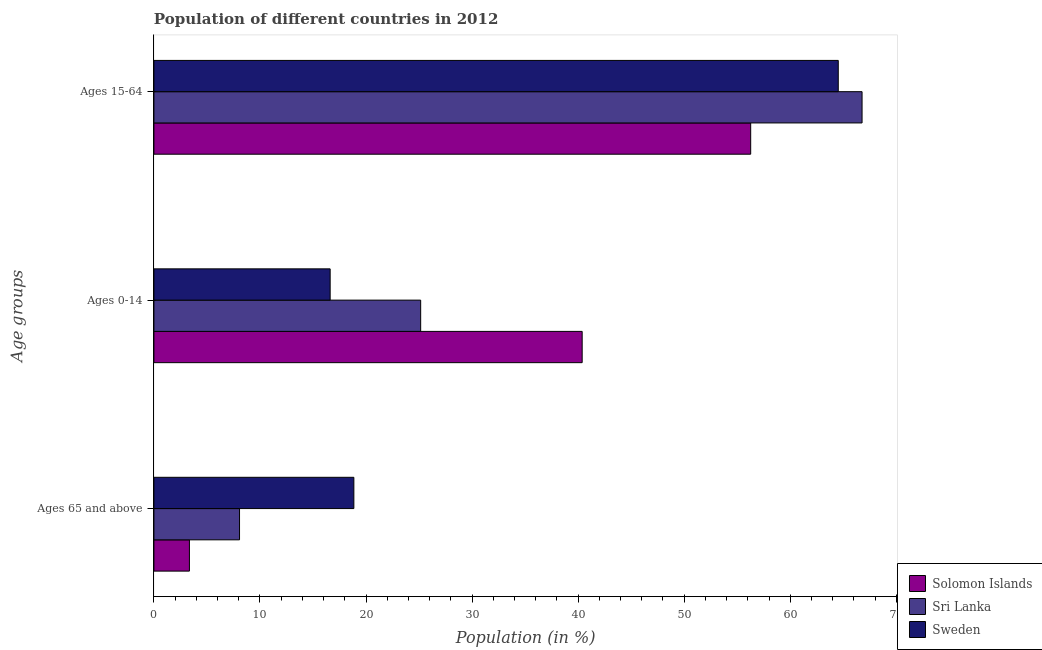How many different coloured bars are there?
Give a very brief answer. 3. Are the number of bars per tick equal to the number of legend labels?
Your answer should be compact. Yes. What is the label of the 1st group of bars from the top?
Make the answer very short. Ages 15-64. What is the percentage of population within the age-group of 65 and above in Sri Lanka?
Offer a very short reply. 8.07. Across all countries, what is the maximum percentage of population within the age-group 15-64?
Offer a very short reply. 66.77. Across all countries, what is the minimum percentage of population within the age-group of 65 and above?
Your response must be concise. 3.35. In which country was the percentage of population within the age-group 15-64 maximum?
Give a very brief answer. Sri Lanka. In which country was the percentage of population within the age-group 15-64 minimum?
Ensure brevity in your answer.  Solomon Islands. What is the total percentage of population within the age-group of 65 and above in the graph?
Make the answer very short. 30.27. What is the difference between the percentage of population within the age-group of 65 and above in Sri Lanka and that in Sweden?
Ensure brevity in your answer.  -10.78. What is the difference between the percentage of population within the age-group of 65 and above in Sri Lanka and the percentage of population within the age-group 15-64 in Sweden?
Provide a succinct answer. -56.46. What is the average percentage of population within the age-group of 65 and above per country?
Keep it short and to the point. 10.09. What is the difference between the percentage of population within the age-group of 65 and above and percentage of population within the age-group 15-64 in Sweden?
Provide a succinct answer. -45.68. What is the ratio of the percentage of population within the age-group 0-14 in Sri Lanka to that in Solomon Islands?
Your answer should be compact. 0.62. Is the difference between the percentage of population within the age-group 15-64 in Sweden and Solomon Islands greater than the difference between the percentage of population within the age-group of 65 and above in Sweden and Solomon Islands?
Ensure brevity in your answer.  No. What is the difference between the highest and the second highest percentage of population within the age-group 0-14?
Your answer should be very brief. 15.23. What is the difference between the highest and the lowest percentage of population within the age-group 0-14?
Make the answer very short. 23.76. What does the 1st bar from the top in Ages 0-14 represents?
Keep it short and to the point. Sweden. What does the 2nd bar from the bottom in Ages 65 and above represents?
Offer a very short reply. Sri Lanka. Is it the case that in every country, the sum of the percentage of population within the age-group of 65 and above and percentage of population within the age-group 0-14 is greater than the percentage of population within the age-group 15-64?
Your answer should be compact. No. How many bars are there?
Provide a succinct answer. 9. How many countries are there in the graph?
Your answer should be compact. 3. What is the difference between two consecutive major ticks on the X-axis?
Provide a short and direct response. 10. How many legend labels are there?
Your answer should be compact. 3. How are the legend labels stacked?
Offer a very short reply. Vertical. What is the title of the graph?
Keep it short and to the point. Population of different countries in 2012. What is the label or title of the X-axis?
Your response must be concise. Population (in %). What is the label or title of the Y-axis?
Provide a short and direct response. Age groups. What is the Population (in %) in Solomon Islands in Ages 65 and above?
Provide a short and direct response. 3.35. What is the Population (in %) of Sri Lanka in Ages 65 and above?
Your answer should be compact. 8.07. What is the Population (in %) in Sweden in Ages 65 and above?
Offer a very short reply. 18.85. What is the Population (in %) in Solomon Islands in Ages 0-14?
Keep it short and to the point. 40.38. What is the Population (in %) in Sri Lanka in Ages 0-14?
Offer a very short reply. 25.15. What is the Population (in %) of Sweden in Ages 0-14?
Provide a succinct answer. 16.62. What is the Population (in %) in Solomon Islands in Ages 15-64?
Your answer should be very brief. 56.27. What is the Population (in %) in Sri Lanka in Ages 15-64?
Offer a terse response. 66.77. What is the Population (in %) of Sweden in Ages 15-64?
Your answer should be very brief. 64.53. Across all Age groups, what is the maximum Population (in %) of Solomon Islands?
Your answer should be very brief. 56.27. Across all Age groups, what is the maximum Population (in %) of Sri Lanka?
Make the answer very short. 66.77. Across all Age groups, what is the maximum Population (in %) in Sweden?
Offer a very short reply. 64.53. Across all Age groups, what is the minimum Population (in %) of Solomon Islands?
Make the answer very short. 3.35. Across all Age groups, what is the minimum Population (in %) in Sri Lanka?
Give a very brief answer. 8.07. Across all Age groups, what is the minimum Population (in %) in Sweden?
Provide a short and direct response. 16.62. What is the difference between the Population (in %) of Solomon Islands in Ages 65 and above and that in Ages 0-14?
Offer a terse response. -37.03. What is the difference between the Population (in %) of Sri Lanka in Ages 65 and above and that in Ages 0-14?
Offer a very short reply. -17.08. What is the difference between the Population (in %) in Sweden in Ages 65 and above and that in Ages 0-14?
Your answer should be very brief. 2.24. What is the difference between the Population (in %) of Solomon Islands in Ages 65 and above and that in Ages 15-64?
Make the answer very short. -52.92. What is the difference between the Population (in %) of Sri Lanka in Ages 65 and above and that in Ages 15-64?
Your answer should be compact. -58.7. What is the difference between the Population (in %) in Sweden in Ages 65 and above and that in Ages 15-64?
Provide a short and direct response. -45.68. What is the difference between the Population (in %) in Solomon Islands in Ages 0-14 and that in Ages 15-64?
Make the answer very short. -15.89. What is the difference between the Population (in %) of Sri Lanka in Ages 0-14 and that in Ages 15-64?
Keep it short and to the point. -41.62. What is the difference between the Population (in %) in Sweden in Ages 0-14 and that in Ages 15-64?
Make the answer very short. -47.91. What is the difference between the Population (in %) in Solomon Islands in Ages 65 and above and the Population (in %) in Sri Lanka in Ages 0-14?
Ensure brevity in your answer.  -21.81. What is the difference between the Population (in %) of Solomon Islands in Ages 65 and above and the Population (in %) of Sweden in Ages 0-14?
Your answer should be compact. -13.27. What is the difference between the Population (in %) of Sri Lanka in Ages 65 and above and the Population (in %) of Sweden in Ages 0-14?
Offer a very short reply. -8.54. What is the difference between the Population (in %) in Solomon Islands in Ages 65 and above and the Population (in %) in Sri Lanka in Ages 15-64?
Give a very brief answer. -63.43. What is the difference between the Population (in %) of Solomon Islands in Ages 65 and above and the Population (in %) of Sweden in Ages 15-64?
Ensure brevity in your answer.  -61.18. What is the difference between the Population (in %) in Sri Lanka in Ages 65 and above and the Population (in %) in Sweden in Ages 15-64?
Offer a very short reply. -56.46. What is the difference between the Population (in %) of Solomon Islands in Ages 0-14 and the Population (in %) of Sri Lanka in Ages 15-64?
Provide a succinct answer. -26.39. What is the difference between the Population (in %) in Solomon Islands in Ages 0-14 and the Population (in %) in Sweden in Ages 15-64?
Offer a very short reply. -24.15. What is the difference between the Population (in %) in Sri Lanka in Ages 0-14 and the Population (in %) in Sweden in Ages 15-64?
Ensure brevity in your answer.  -39.38. What is the average Population (in %) of Solomon Islands per Age groups?
Provide a short and direct response. 33.33. What is the average Population (in %) in Sri Lanka per Age groups?
Make the answer very short. 33.33. What is the average Population (in %) of Sweden per Age groups?
Your answer should be compact. 33.33. What is the difference between the Population (in %) of Solomon Islands and Population (in %) of Sri Lanka in Ages 65 and above?
Make the answer very short. -4.72. What is the difference between the Population (in %) in Solomon Islands and Population (in %) in Sweden in Ages 65 and above?
Provide a succinct answer. -15.51. What is the difference between the Population (in %) of Sri Lanka and Population (in %) of Sweden in Ages 65 and above?
Give a very brief answer. -10.78. What is the difference between the Population (in %) in Solomon Islands and Population (in %) in Sri Lanka in Ages 0-14?
Your response must be concise. 15.23. What is the difference between the Population (in %) of Solomon Islands and Population (in %) of Sweden in Ages 0-14?
Offer a very short reply. 23.76. What is the difference between the Population (in %) of Sri Lanka and Population (in %) of Sweden in Ages 0-14?
Provide a short and direct response. 8.54. What is the difference between the Population (in %) in Solomon Islands and Population (in %) in Sri Lanka in Ages 15-64?
Make the answer very short. -10.5. What is the difference between the Population (in %) in Solomon Islands and Population (in %) in Sweden in Ages 15-64?
Provide a succinct answer. -8.26. What is the difference between the Population (in %) of Sri Lanka and Population (in %) of Sweden in Ages 15-64?
Your answer should be very brief. 2.24. What is the ratio of the Population (in %) in Solomon Islands in Ages 65 and above to that in Ages 0-14?
Provide a succinct answer. 0.08. What is the ratio of the Population (in %) of Sri Lanka in Ages 65 and above to that in Ages 0-14?
Your response must be concise. 0.32. What is the ratio of the Population (in %) of Sweden in Ages 65 and above to that in Ages 0-14?
Offer a terse response. 1.13. What is the ratio of the Population (in %) of Solomon Islands in Ages 65 and above to that in Ages 15-64?
Provide a short and direct response. 0.06. What is the ratio of the Population (in %) of Sri Lanka in Ages 65 and above to that in Ages 15-64?
Your response must be concise. 0.12. What is the ratio of the Population (in %) in Sweden in Ages 65 and above to that in Ages 15-64?
Your answer should be compact. 0.29. What is the ratio of the Population (in %) in Solomon Islands in Ages 0-14 to that in Ages 15-64?
Keep it short and to the point. 0.72. What is the ratio of the Population (in %) of Sri Lanka in Ages 0-14 to that in Ages 15-64?
Provide a succinct answer. 0.38. What is the ratio of the Population (in %) in Sweden in Ages 0-14 to that in Ages 15-64?
Make the answer very short. 0.26. What is the difference between the highest and the second highest Population (in %) of Solomon Islands?
Offer a terse response. 15.89. What is the difference between the highest and the second highest Population (in %) of Sri Lanka?
Give a very brief answer. 41.62. What is the difference between the highest and the second highest Population (in %) in Sweden?
Offer a terse response. 45.68. What is the difference between the highest and the lowest Population (in %) in Solomon Islands?
Give a very brief answer. 52.92. What is the difference between the highest and the lowest Population (in %) in Sri Lanka?
Provide a succinct answer. 58.7. What is the difference between the highest and the lowest Population (in %) of Sweden?
Ensure brevity in your answer.  47.91. 